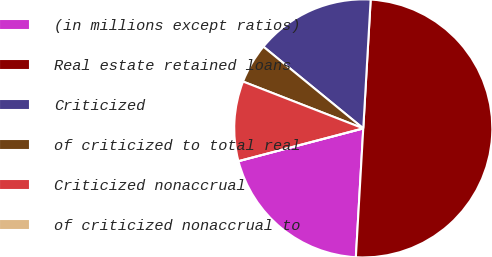<chart> <loc_0><loc_0><loc_500><loc_500><pie_chart><fcel>(in millions except ratios)<fcel>Real estate retained loans<fcel>Criticized<fcel>of criticized to total real<fcel>Criticized nonaccrual<fcel>of criticized nonaccrual to<nl><fcel>20.0%<fcel>50.0%<fcel>15.0%<fcel>5.0%<fcel>10.0%<fcel>0.0%<nl></chart> 